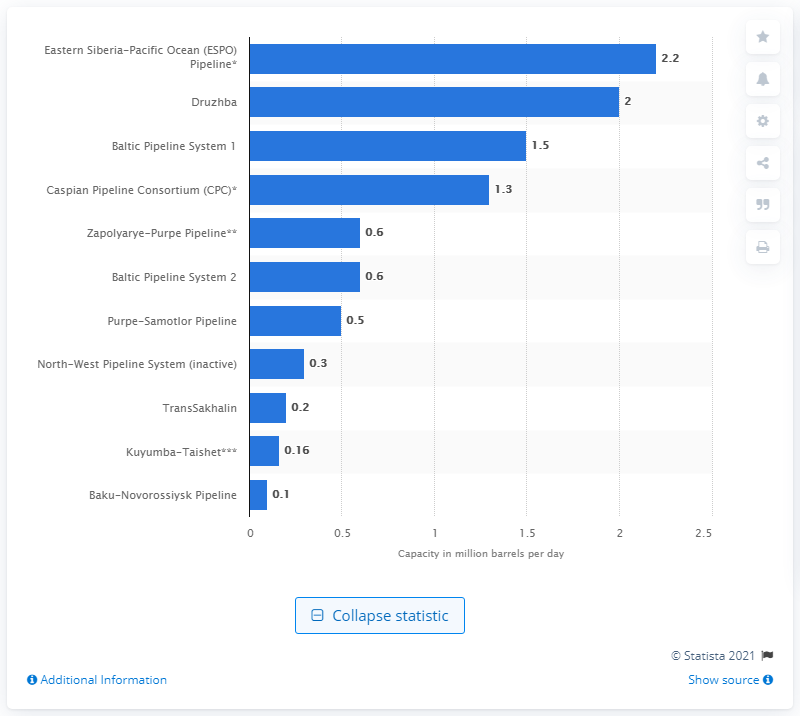List a handful of essential elements in this visual. The Druzhba pipeline has the second-largest capacity in Russia. 